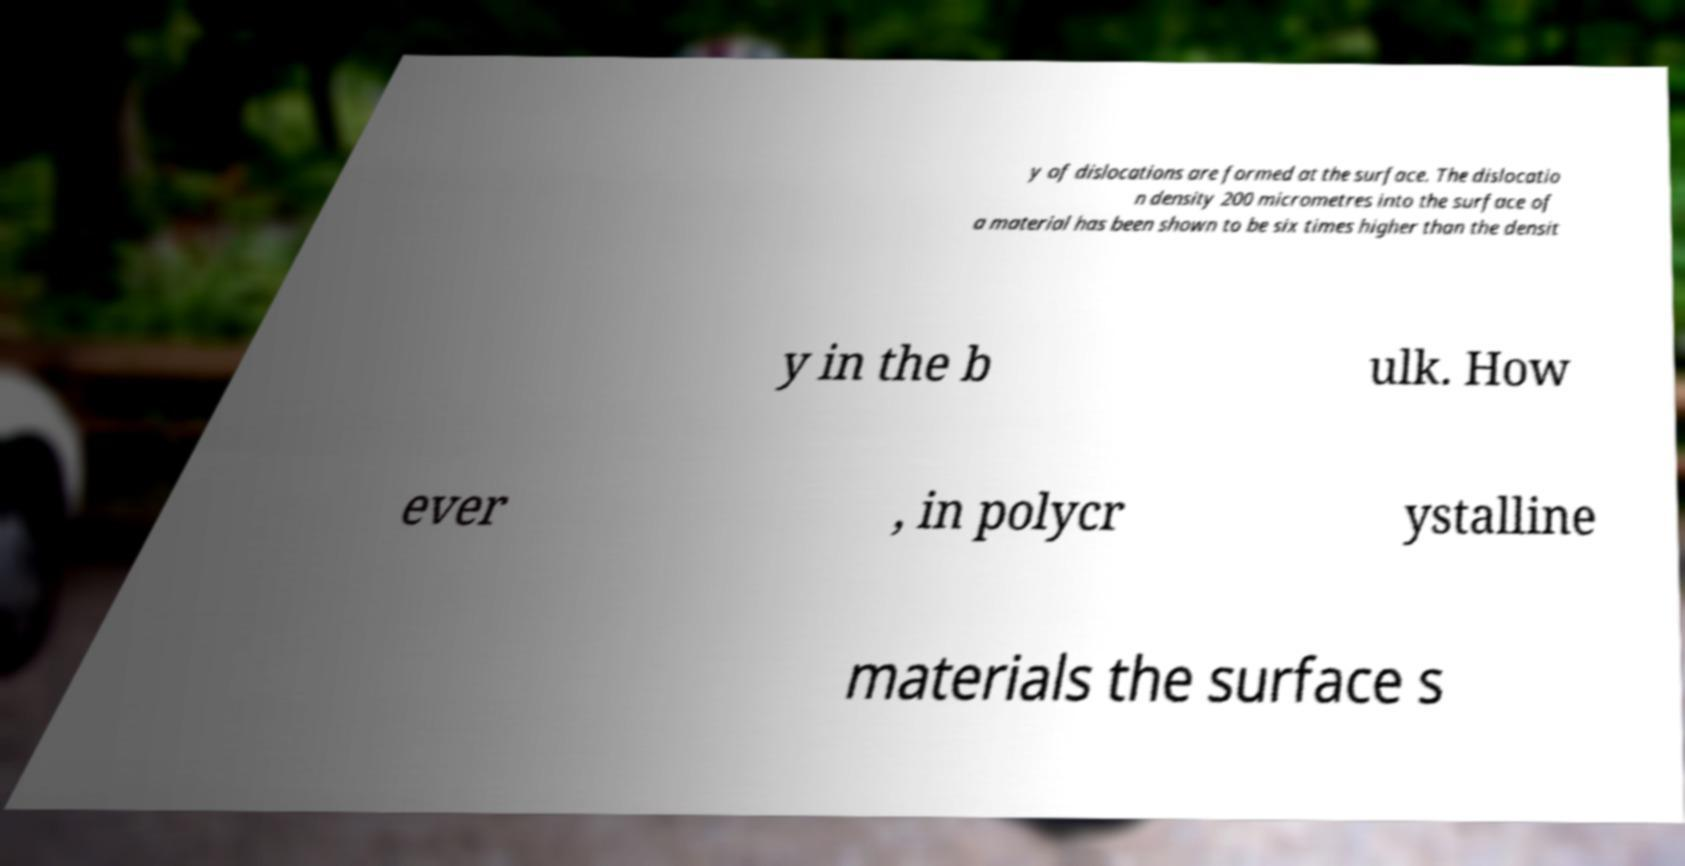Can you read and provide the text displayed in the image?This photo seems to have some interesting text. Can you extract and type it out for me? y of dislocations are formed at the surface. The dislocatio n density 200 micrometres into the surface of a material has been shown to be six times higher than the densit y in the b ulk. How ever , in polycr ystalline materials the surface s 